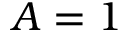<formula> <loc_0><loc_0><loc_500><loc_500>{ A = 1 }</formula> 